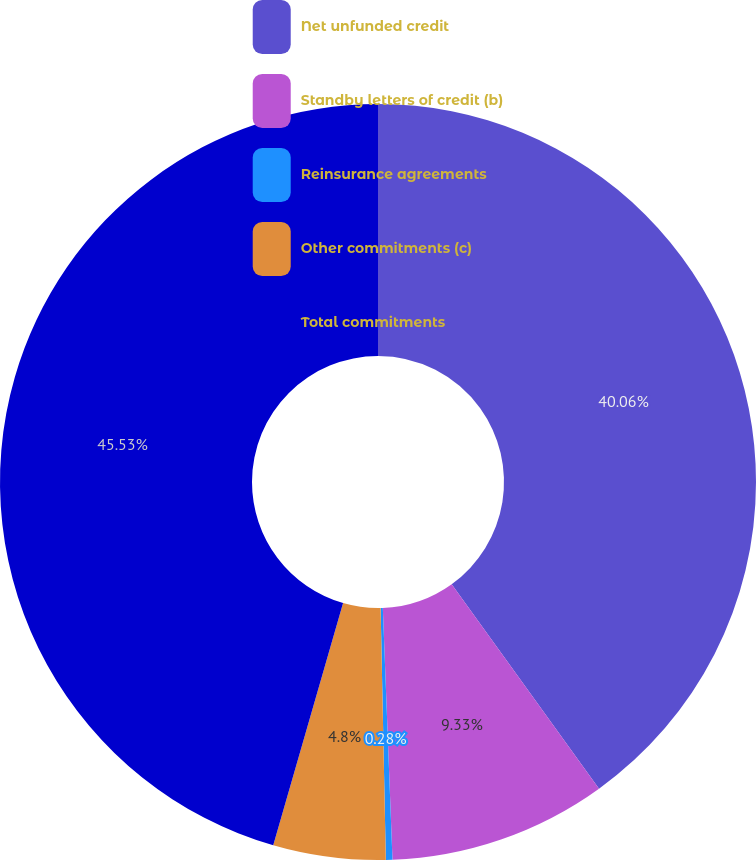Convert chart to OTSL. <chart><loc_0><loc_0><loc_500><loc_500><pie_chart><fcel>Net unfunded credit<fcel>Standby letters of credit (b)<fcel>Reinsurance agreements<fcel>Other commitments (c)<fcel>Total commitments<nl><fcel>40.06%<fcel>9.33%<fcel>0.28%<fcel>4.8%<fcel>45.53%<nl></chart> 